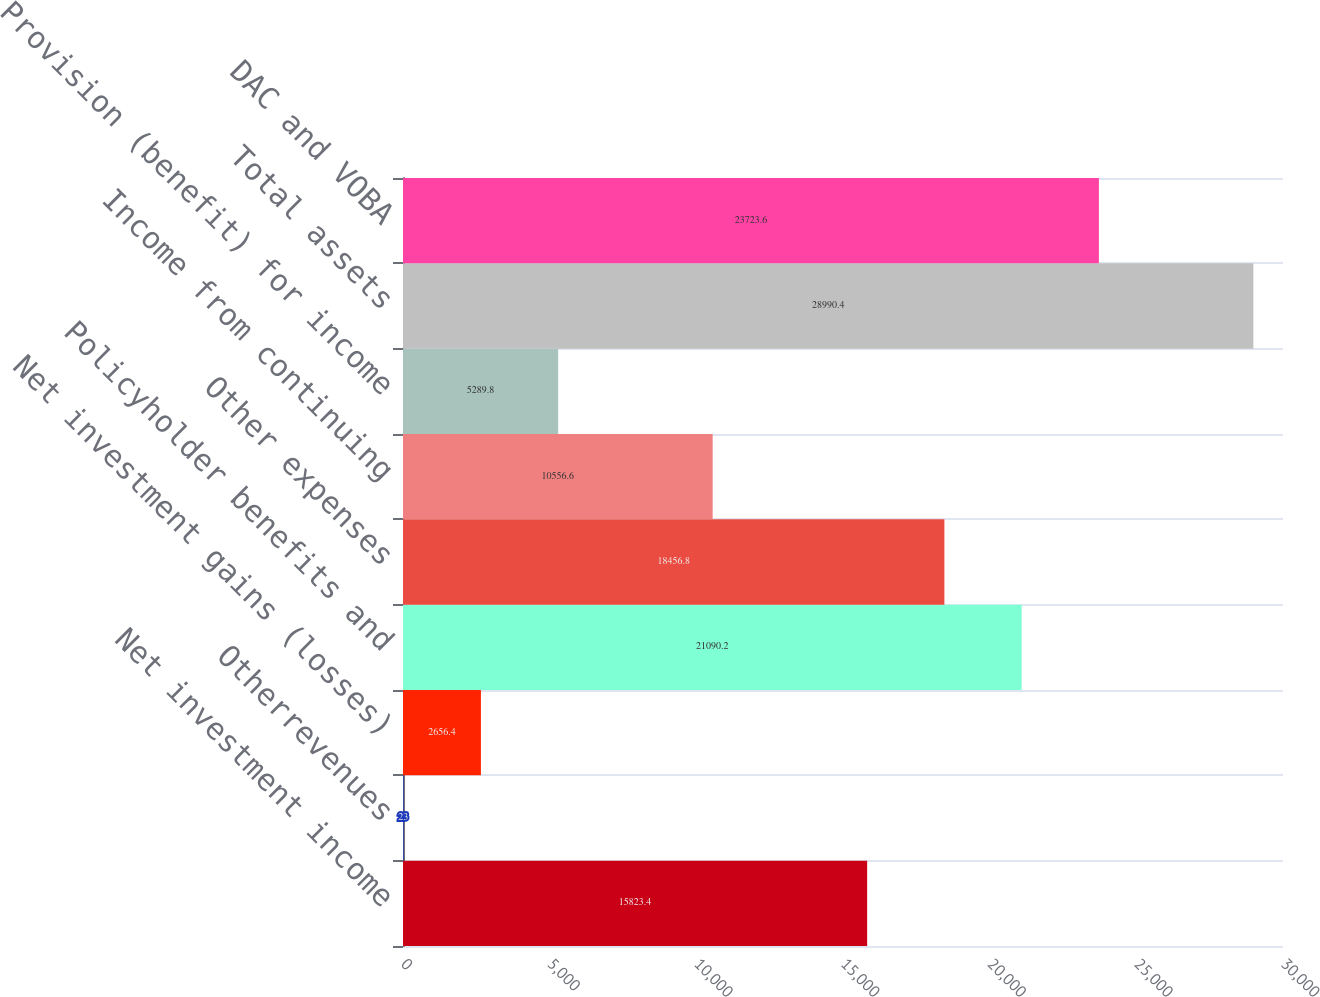<chart> <loc_0><loc_0><loc_500><loc_500><bar_chart><fcel>Net investment income<fcel>Otherrevenues<fcel>Net investment gains (losses)<fcel>Policyholder benefits and<fcel>Other expenses<fcel>Income from continuing<fcel>Provision (benefit) for income<fcel>Total assets<fcel>DAC and VOBA<nl><fcel>15823.4<fcel>23<fcel>2656.4<fcel>21090.2<fcel>18456.8<fcel>10556.6<fcel>5289.8<fcel>28990.4<fcel>23723.6<nl></chart> 